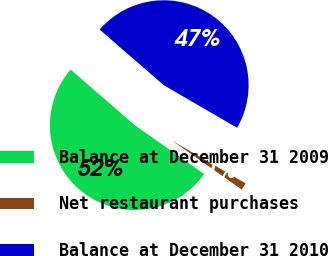Convert chart. <chart><loc_0><loc_0><loc_500><loc_500><pie_chart><fcel>Balance at December 31 2009<fcel>Net restaurant purchases<fcel>Balance at December 31 2010<nl><fcel>51.61%<fcel>1.38%<fcel>47.01%<nl></chart> 